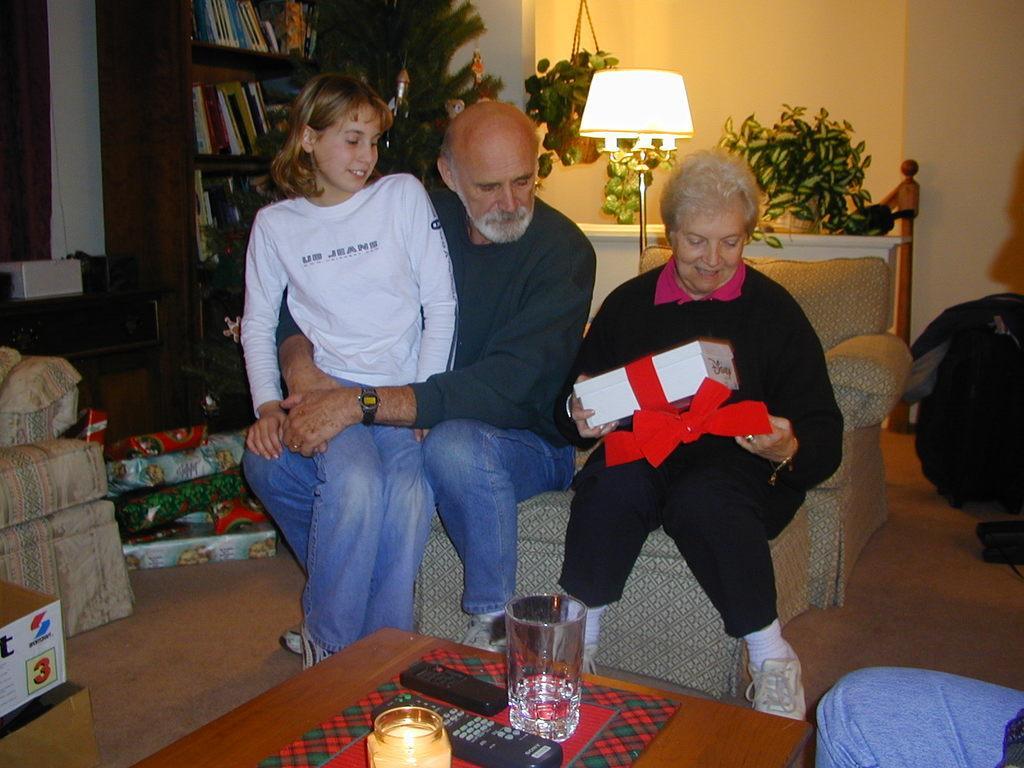Describe this image in one or two sentences. This 3 persons are sitting on a couch. This woman is holding a box with ribbon. Rack is filled with books. Far there is a lantern lamp with pole. On this table there are plants. On floor there are gifts. On this table there is a remote, jar and glass. 